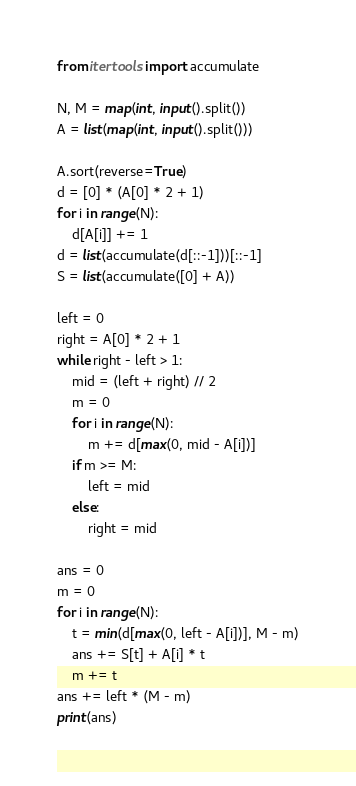Convert code to text. <code><loc_0><loc_0><loc_500><loc_500><_Python_>from itertools import accumulate

N, M = map(int, input().split())
A = list(map(int, input().split()))

A.sort(reverse=True)
d = [0] * (A[0] * 2 + 1)
for i in range(N):
    d[A[i]] += 1
d = list(accumulate(d[::-1]))[::-1]
S = list(accumulate([0] + A))

left = 0
right = A[0] * 2 + 1
while right - left > 1:
    mid = (left + right) // 2
    m = 0
    for i in range(N):
        m += d[max(0, mid - A[i])]
    if m >= M:
        left = mid
    else:
        right = mid

ans = 0
m = 0
for i in range(N):
    t = min(d[max(0, left - A[i])], M - m)
    ans += S[t] + A[i] * t
    m += t
ans += left * (M - m)
print(ans)
</code> 